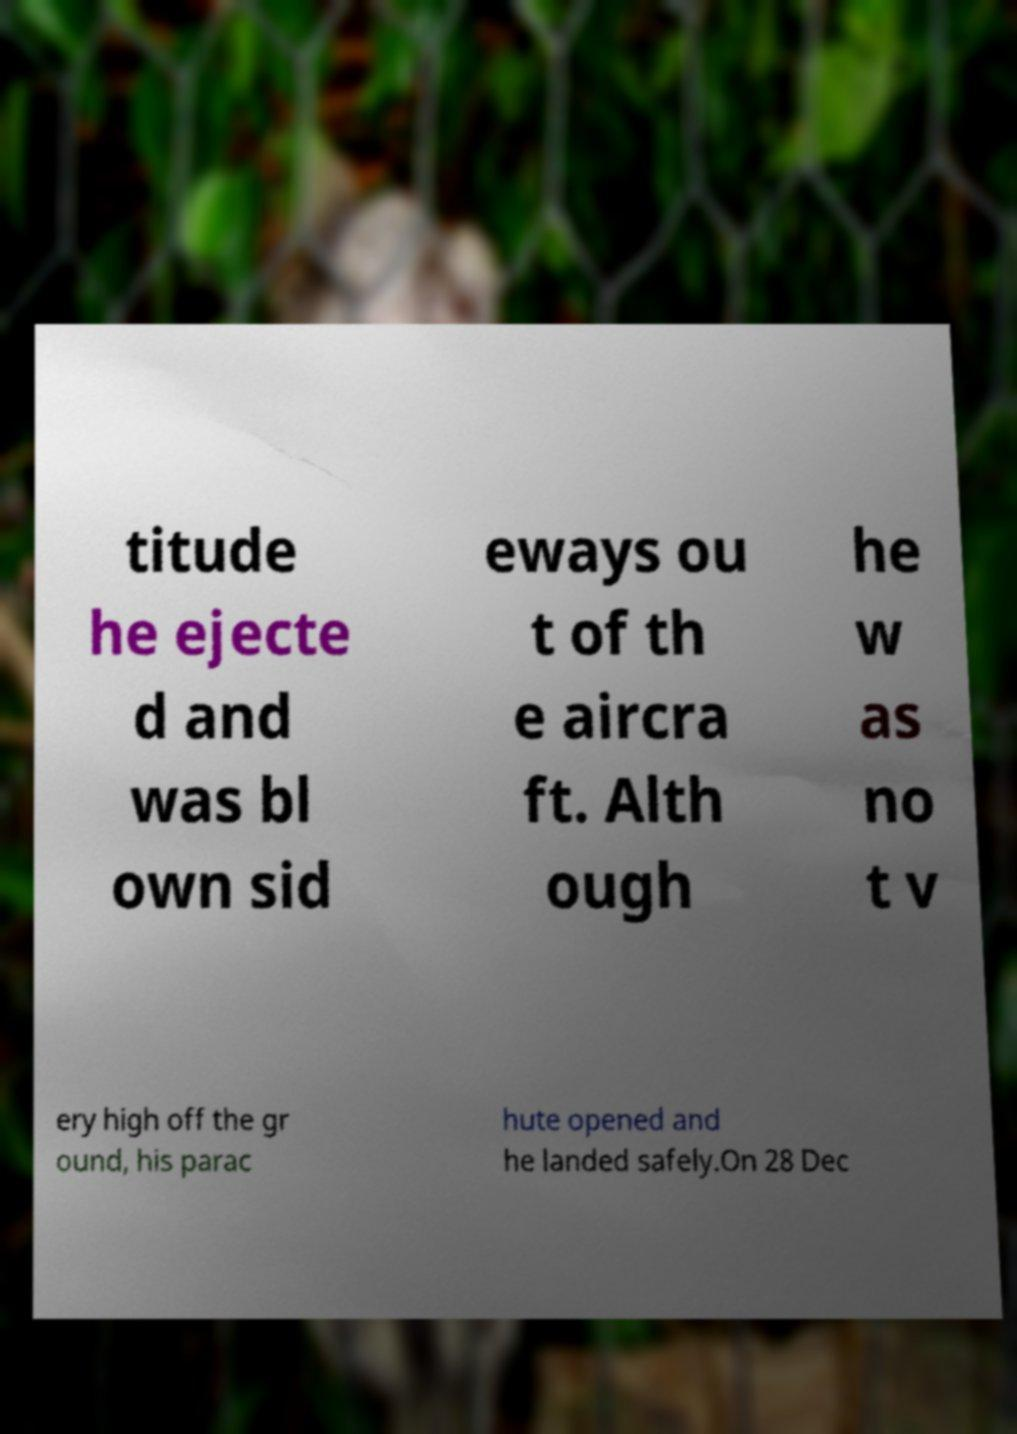Could you extract and type out the text from this image? titude he ejecte d and was bl own sid eways ou t of th e aircra ft. Alth ough he w as no t v ery high off the gr ound, his parac hute opened and he landed safely.On 28 Dec 